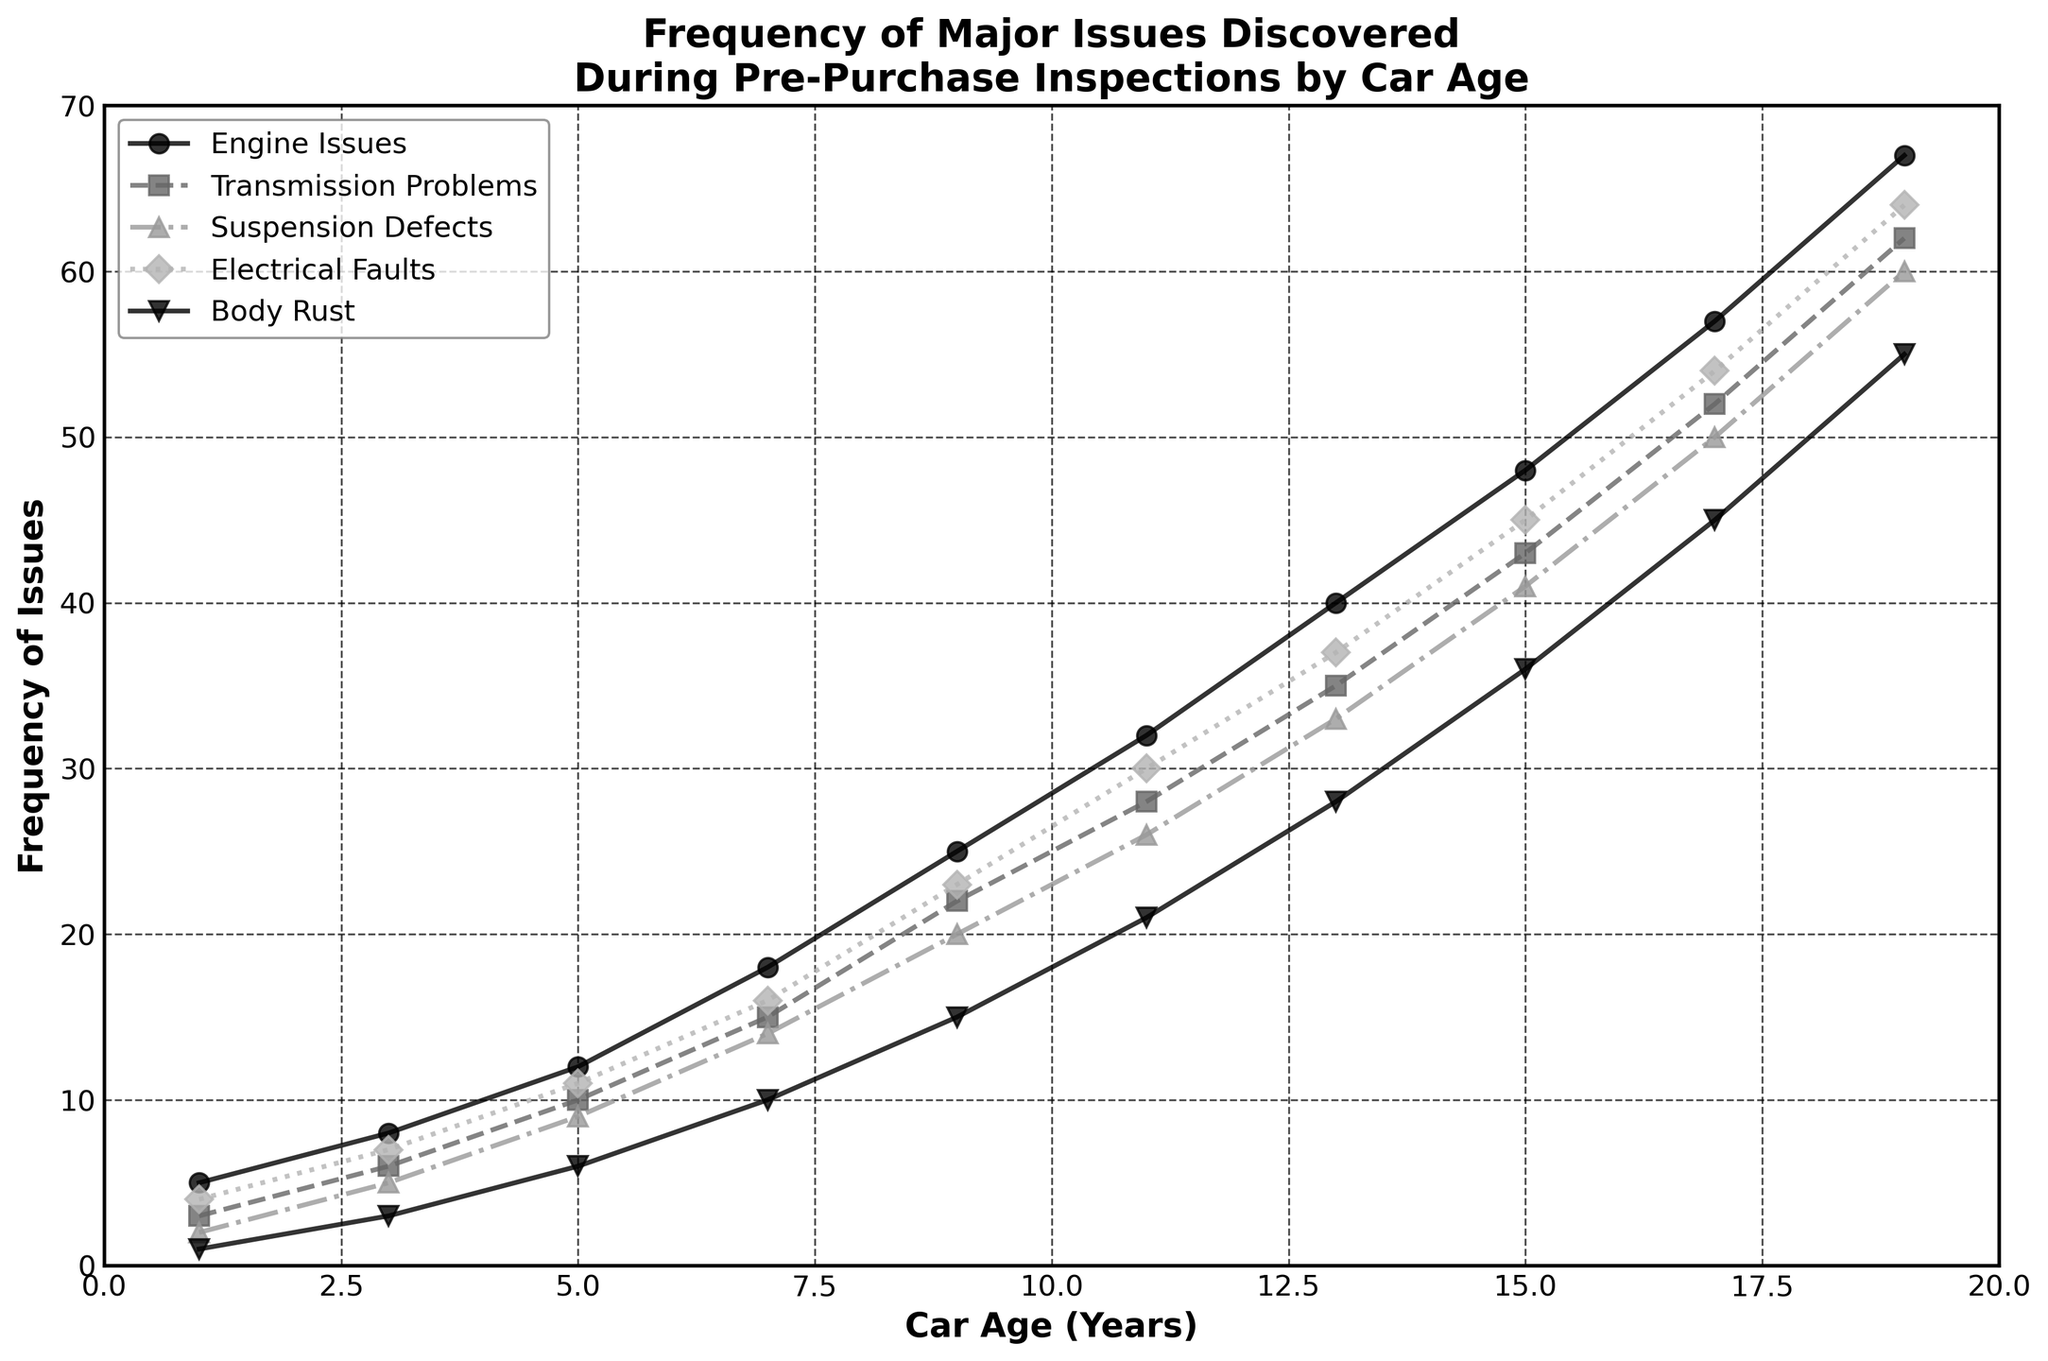What issue is the most frequently discovered in pre-purchase inspections for cars aged 15 years? By looking at the graph for the age of 15 years, the highest line will indicate the most frequently discovered issue. That line corresponds to Engine Issues.
Answer: Engine Issues Does the frequency of Electrical Faults increase steadily with car age? By examining the slope of the line representing Electrical Faults from year 1 to year 19, it is clear that the line consistently increases.
Answer: Yes At what car age do Transmission Problems exceed Suspension Defects for the first time? By locating the intersection between the lines for Transmission Problems and Suspension Defects and identifying the corresponding age on the x-axis, this occurs around age 5.
Answer: 5 By how much does the frequency of Engine Issues exceed Body Rust in cars aged 9 years? At age 9, the frequency of Engine Issues is 25, and Body Rust is 15. The difference is 25 - 15 = 10.
Answer: 10 What is the average frequency of Suspension Defects discovered in cars between the ages of 1 and 10 years? The frequencies from ages 1 to 9 years are 2, 5, 9, 14, 20, and 26. Summing these up results in 2 + 5 + 9 + 14 + 20 + 26 = 76. The average over 6 values is 76 / 6 = 12.67.
Answer: 12.67 Is the frequency of Body Rust higher in 15-year-old cars than Electrical Faults in 11-year-old cars? Compare the values for Body Rust at age 15 (36) with Electrical Faults at age 11 (30). Since 36 > 30, the frequency of Body Rust is indeed higher.
Answer: Yes What is the total frequency of major issues discovered in cars aged 5 years? Sum the frequencies of all issues at age 5: 12 (Engine Issues) + 10 (Transmission Problems) + 9 (Suspension Defects) + 11 (Electrical Faults) + 6 (Body Rust) = 48.
Answer: 48 Which issue shows the greatest increase in frequency between cars aged 1 and 19 years? Compare the frequency values at ages 1 and 19 for each issue: Engine Issues (67 - 5 = 62), Transmission Problems (62 - 3 = 59), Suspension Defects (50 - 2 = 48), Electrical Faults (64 - 4 = 60), Body Rust (55 - 1 = 54). Engine Issues show the greatest increase (62).
Answer: Engine Issues How does the frequency of Suspension Defects in 7-year-old cars compare to Electrical Faults in 7-year-old cars? At age 7, look at the values for Suspension Defects (14) and Electrical Faults (16). Since 14 < 16, Suspension Defects are less frequent.
Answer: Less frequent 